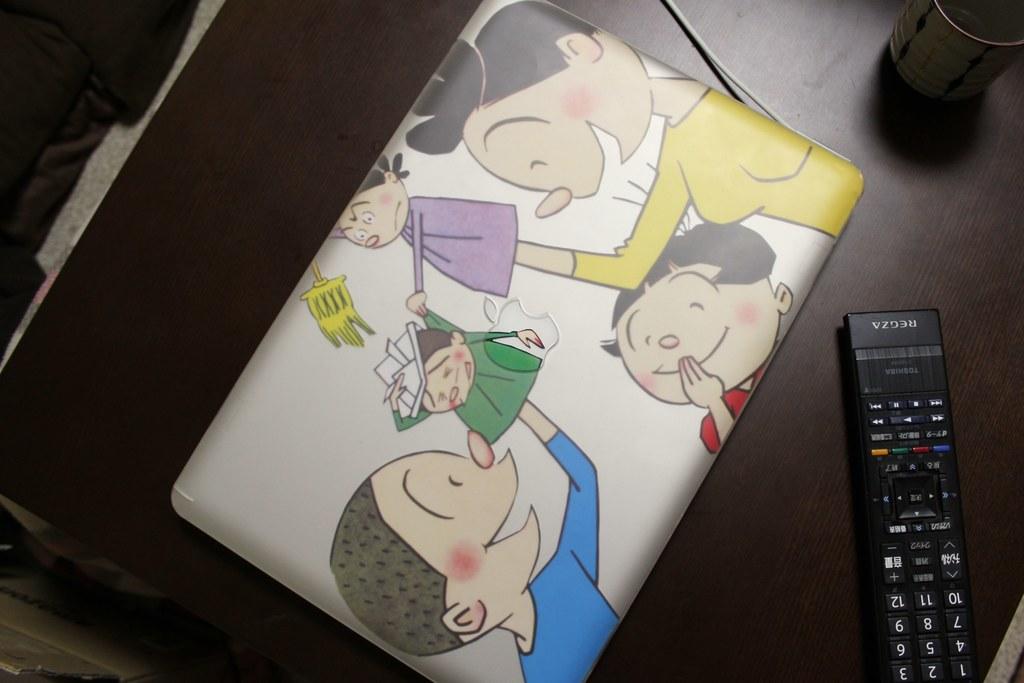What number is upside down in the top left of the remote?
Give a very brief answer. 1. 